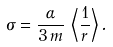Convert formula to latex. <formula><loc_0><loc_0><loc_500><loc_500>\sigma = \frac { \alpha } { 3 \, m } \, \left \langle \frac { 1 } { r } \right \rangle .</formula> 